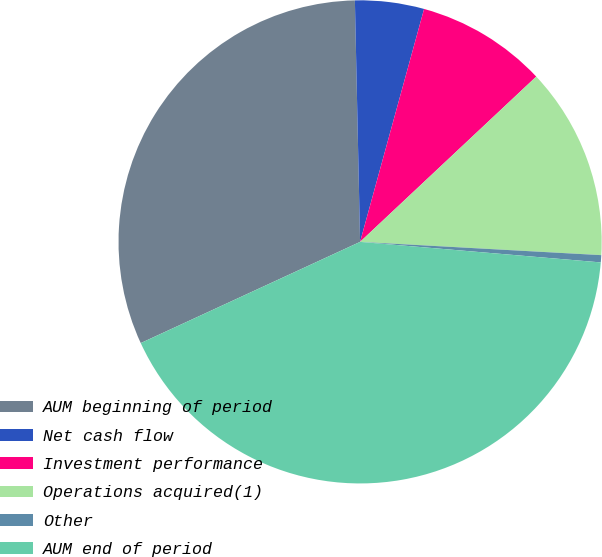Convert chart. <chart><loc_0><loc_0><loc_500><loc_500><pie_chart><fcel>AUM beginning of period<fcel>Net cash flow<fcel>Investment performance<fcel>Operations acquired(1)<fcel>Other<fcel>AUM end of period<nl><fcel>31.54%<fcel>4.61%<fcel>8.74%<fcel>12.87%<fcel>0.48%<fcel>41.77%<nl></chart> 